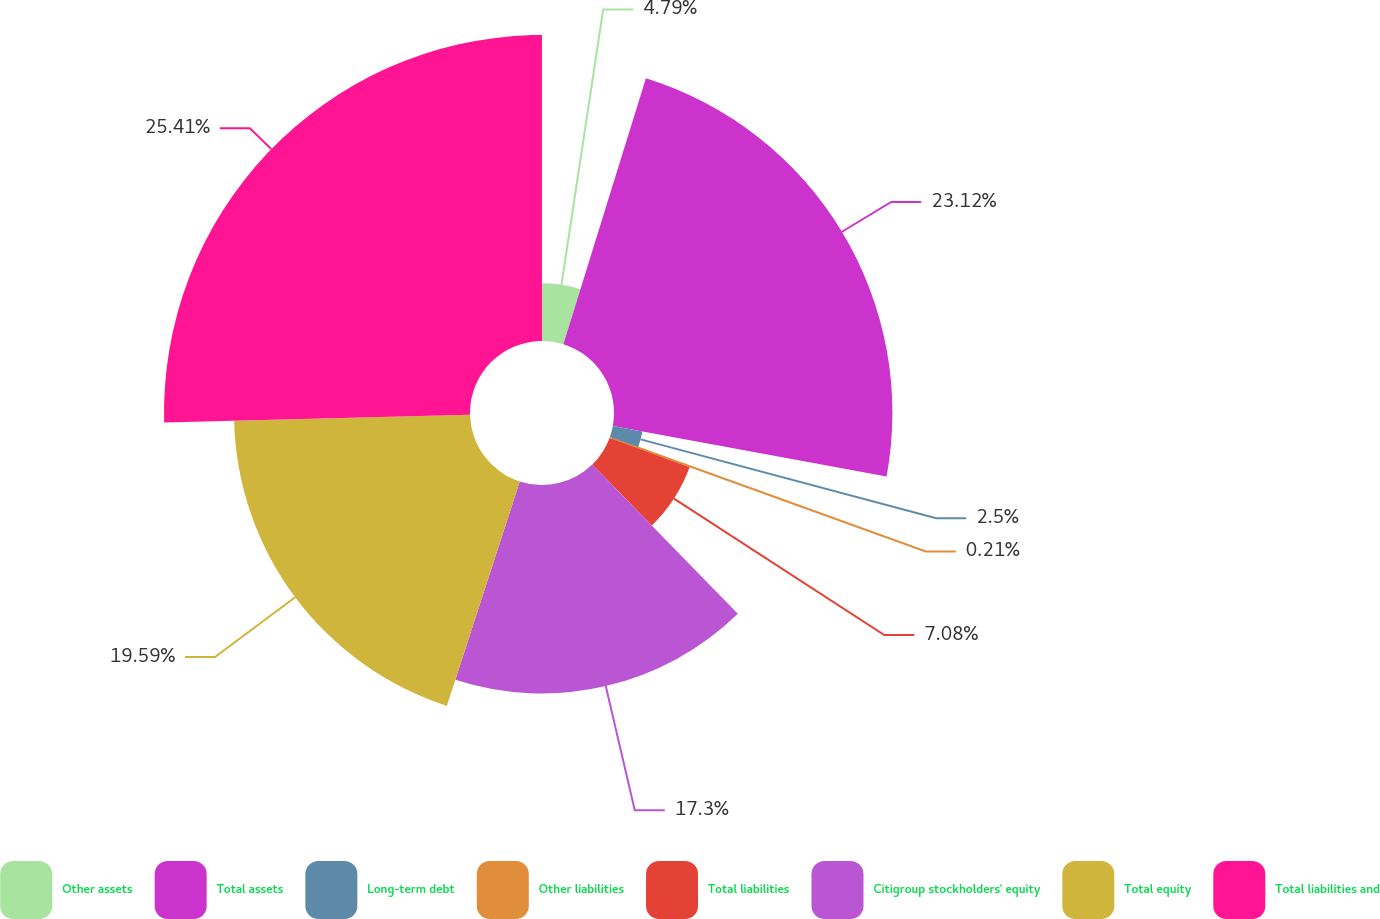<chart> <loc_0><loc_0><loc_500><loc_500><pie_chart><fcel>Other assets<fcel>Total assets<fcel>Long-term debt<fcel>Other liabilities<fcel>Total liabilities<fcel>Citigroup stockholders' equity<fcel>Total equity<fcel>Total liabilities and<nl><fcel>4.79%<fcel>23.11%<fcel>2.5%<fcel>0.21%<fcel>7.08%<fcel>17.3%<fcel>19.59%<fcel>25.4%<nl></chart> 